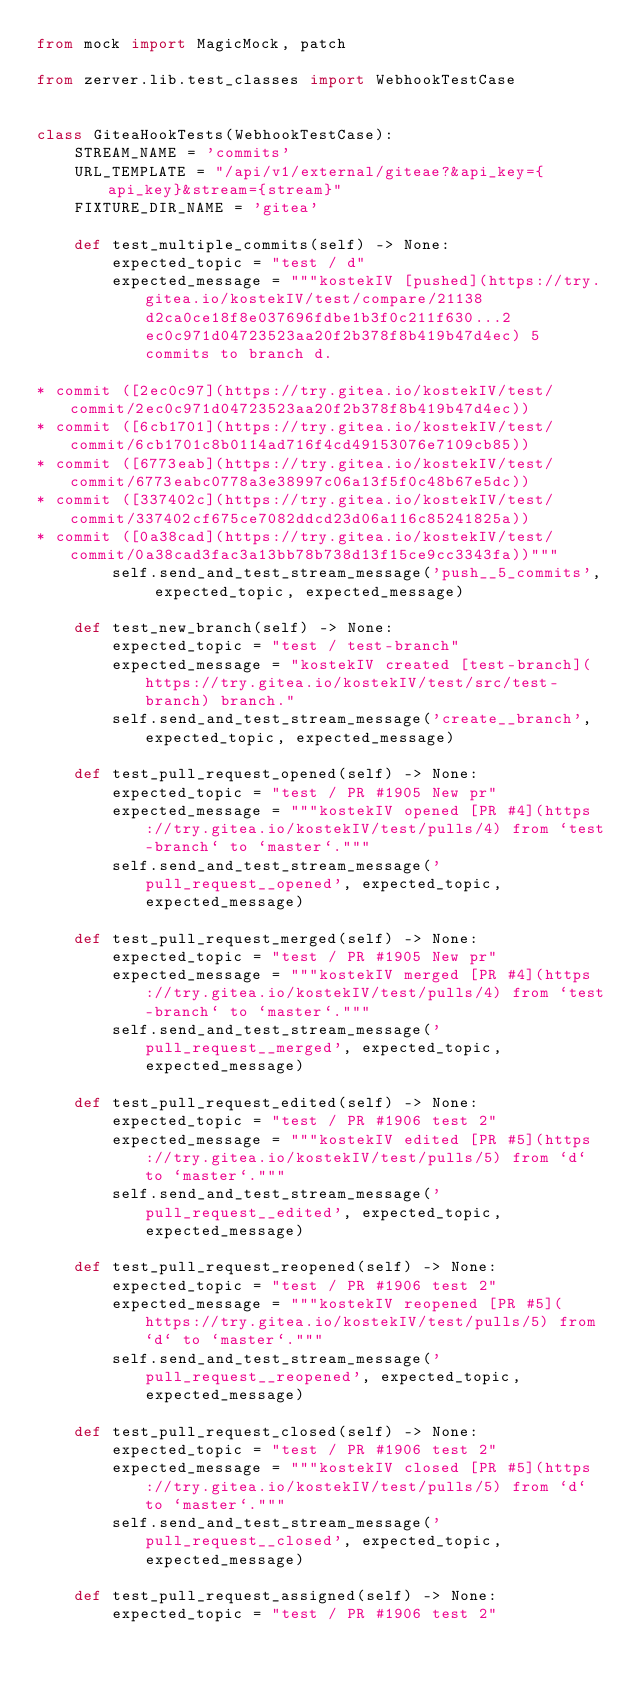Convert code to text. <code><loc_0><loc_0><loc_500><loc_500><_Python_>from mock import MagicMock, patch

from zerver.lib.test_classes import WebhookTestCase


class GiteaHookTests(WebhookTestCase):
    STREAM_NAME = 'commits'
    URL_TEMPLATE = "/api/v1/external/giteae?&api_key={api_key}&stream={stream}"
    FIXTURE_DIR_NAME = 'gitea'

    def test_multiple_commits(self) -> None:
        expected_topic = "test / d"
        expected_message = """kostekIV [pushed](https://try.gitea.io/kostekIV/test/compare/21138d2ca0ce18f8e037696fdbe1b3f0c211f630...2ec0c971d04723523aa20f2b378f8b419b47d4ec) 5 commits to branch d.

* commit ([2ec0c97](https://try.gitea.io/kostekIV/test/commit/2ec0c971d04723523aa20f2b378f8b419b47d4ec))
* commit ([6cb1701](https://try.gitea.io/kostekIV/test/commit/6cb1701c8b0114ad716f4cd49153076e7109cb85))
* commit ([6773eab](https://try.gitea.io/kostekIV/test/commit/6773eabc0778a3e38997c06a13f5f0c48b67e5dc))
* commit ([337402c](https://try.gitea.io/kostekIV/test/commit/337402cf675ce7082ddcd23d06a116c85241825a))
* commit ([0a38cad](https://try.gitea.io/kostekIV/test/commit/0a38cad3fac3a13bb78b738d13f15ce9cc3343fa))"""
        self.send_and_test_stream_message('push__5_commits', expected_topic, expected_message)

    def test_new_branch(self) -> None:
        expected_topic = "test / test-branch"
        expected_message = "kostekIV created [test-branch](https://try.gitea.io/kostekIV/test/src/test-branch) branch."
        self.send_and_test_stream_message('create__branch', expected_topic, expected_message)

    def test_pull_request_opened(self) -> None:
        expected_topic = "test / PR #1905 New pr"
        expected_message = """kostekIV opened [PR #4](https://try.gitea.io/kostekIV/test/pulls/4) from `test-branch` to `master`."""
        self.send_and_test_stream_message('pull_request__opened', expected_topic, expected_message)

    def test_pull_request_merged(self) -> None:
        expected_topic = "test / PR #1905 New pr"
        expected_message = """kostekIV merged [PR #4](https://try.gitea.io/kostekIV/test/pulls/4) from `test-branch` to `master`."""
        self.send_and_test_stream_message('pull_request__merged', expected_topic, expected_message)

    def test_pull_request_edited(self) -> None:
        expected_topic = "test / PR #1906 test 2"
        expected_message = """kostekIV edited [PR #5](https://try.gitea.io/kostekIV/test/pulls/5) from `d` to `master`."""
        self.send_and_test_stream_message('pull_request__edited', expected_topic, expected_message)

    def test_pull_request_reopened(self) -> None:
        expected_topic = "test / PR #1906 test 2"
        expected_message = """kostekIV reopened [PR #5](https://try.gitea.io/kostekIV/test/pulls/5) from `d` to `master`."""
        self.send_and_test_stream_message('pull_request__reopened', expected_topic, expected_message)

    def test_pull_request_closed(self) -> None:
        expected_topic = "test / PR #1906 test 2"
        expected_message = """kostekIV closed [PR #5](https://try.gitea.io/kostekIV/test/pulls/5) from `d` to `master`."""
        self.send_and_test_stream_message('pull_request__closed', expected_topic, expected_message)

    def test_pull_request_assigned(self) -> None:
        expected_topic = "test / PR #1906 test 2"</code> 